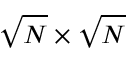<formula> <loc_0><loc_0><loc_500><loc_500>\sqrt { N } \times \sqrt { N }</formula> 